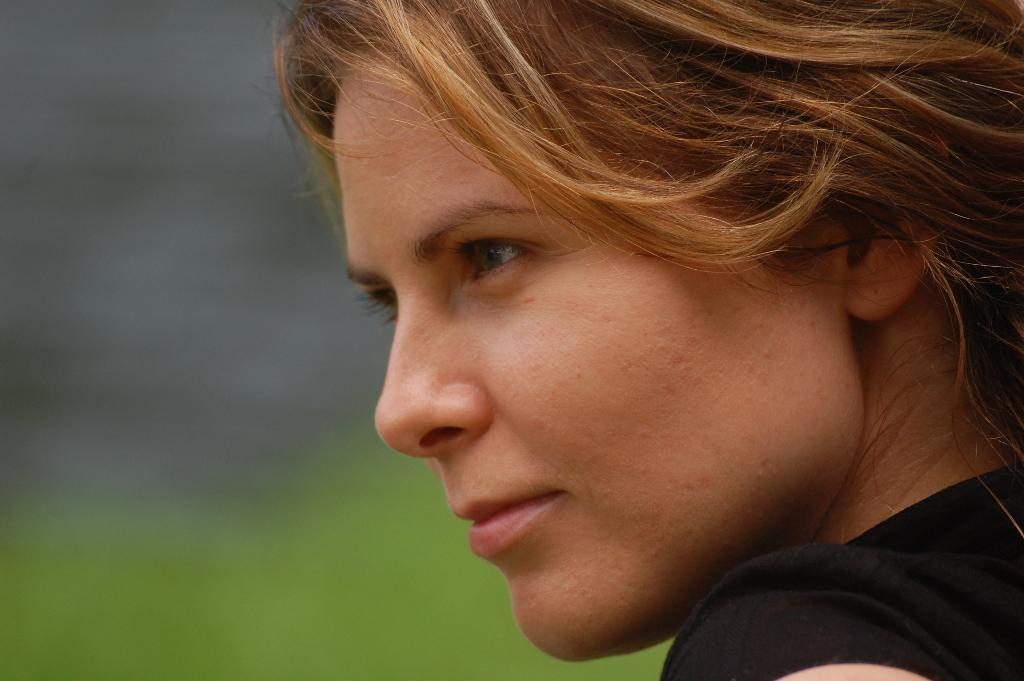Who is present in the image? There is a woman in the image. What letters are visible on the ocean in the image? There is no ocean or letters present in the image; it only features a woman. 